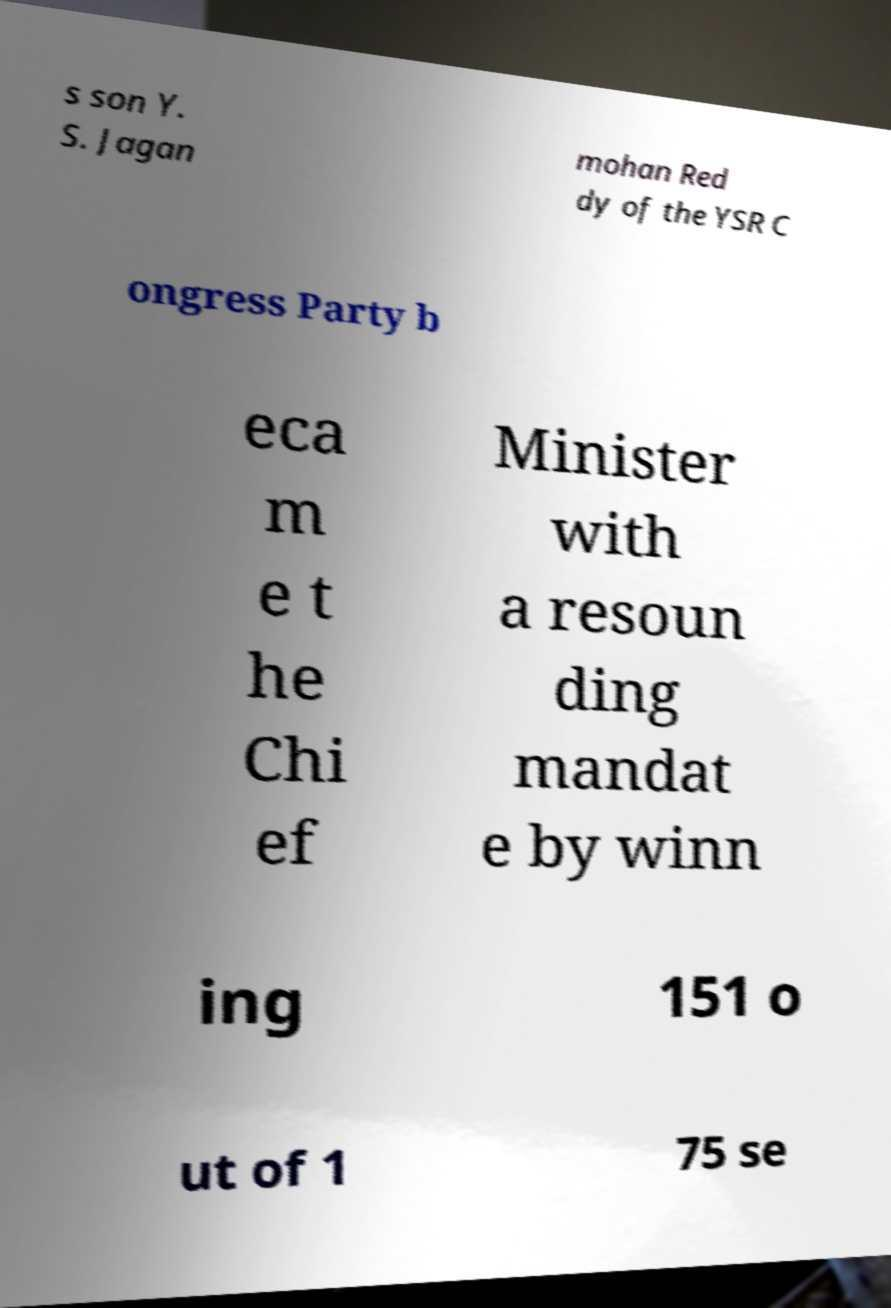Please read and relay the text visible in this image. What does it say? s son Y. S. Jagan mohan Red dy of the YSR C ongress Party b eca m e t he Chi ef Minister with a resoun ding mandat e by winn ing 151 o ut of 1 75 se 